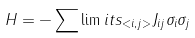Convert formula to latex. <formula><loc_0><loc_0><loc_500><loc_500>H = - \sum \lim i t s _ { < i , j > } J _ { i j } \sigma _ { i } \sigma _ { j }</formula> 